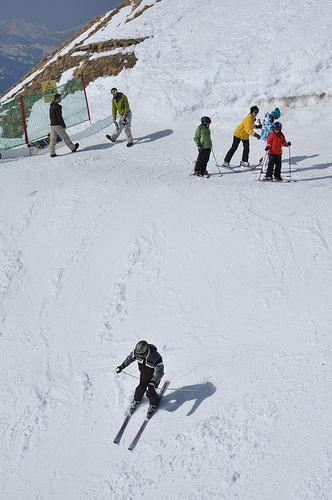Question: who is walking?
Choices:
A. Man in red.
B. Man in brown.
C. Man in blue.
D. Man in green.
Answer with the letter. Answer: B Question: what is everyone doing?
Choices:
A. Skiing.
B. Sledding.
C. Snowboarding.
D. Surfing.
Answer with the letter. Answer: A Question: what is covering the ground?
Choices:
A. Water.
B. Snow.
C. Hail.
D. Leaves.
Answer with the letter. Answer: B Question: where was this photo taken?
Choices:
A. On a snowy mountain.
B. In the cabin.
C. At the bar.
D. In the kennel.
Answer with the letter. Answer: A Question: when was this photo taken?
Choices:
A. Daytime.
B. At night.
C. At dawn.
D. At dusk.
Answer with the letter. Answer: A Question: what are the children doing?
Choices:
A. Skiing.
B. Waiting to ski.
C. Sledding.
D. Sitting.
Answer with the letter. Answer: B 